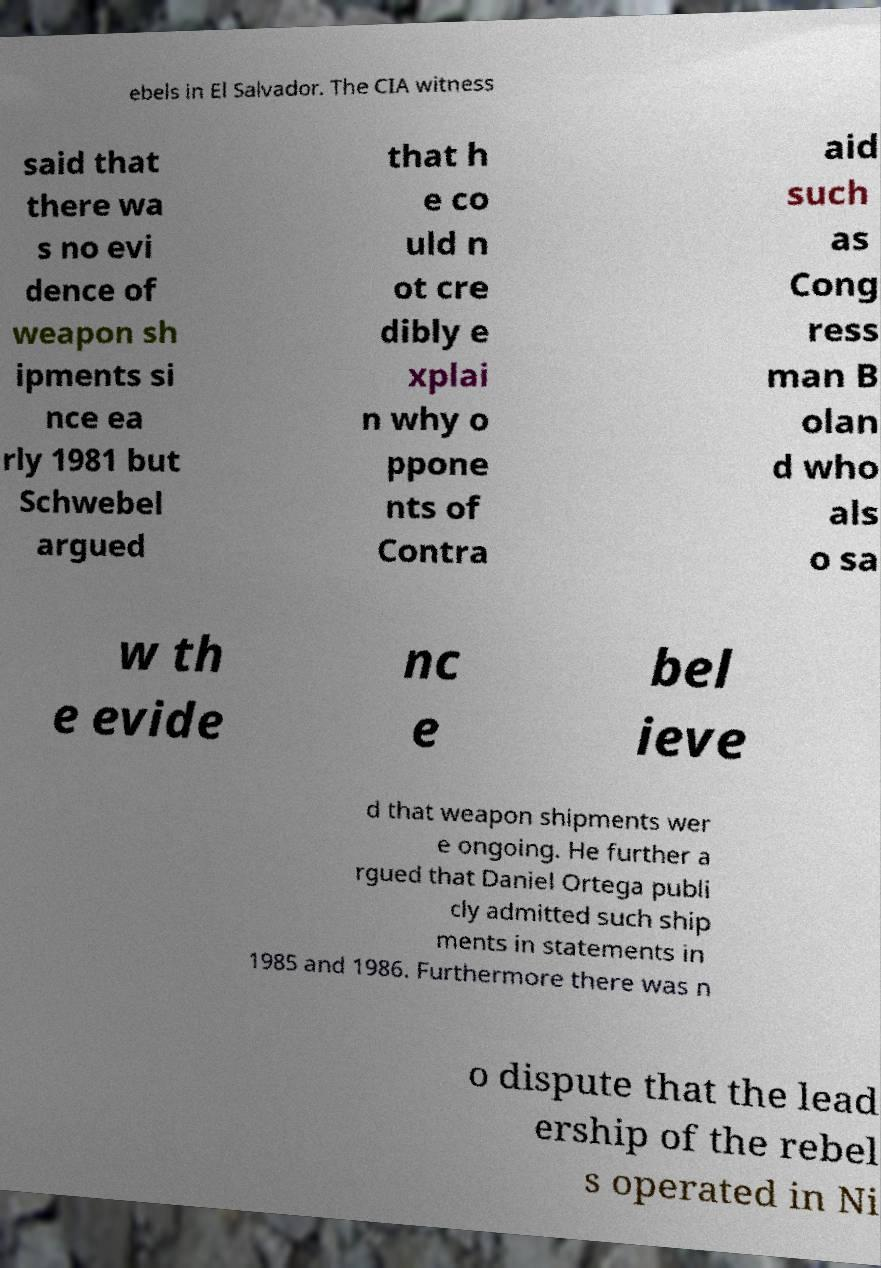Please identify and transcribe the text found in this image. ebels in El Salvador. The CIA witness said that there wa s no evi dence of weapon sh ipments si nce ea rly 1981 but Schwebel argued that h e co uld n ot cre dibly e xplai n why o ppone nts of Contra aid such as Cong ress man B olan d who als o sa w th e evide nc e bel ieve d that weapon shipments wer e ongoing. He further a rgued that Daniel Ortega publi cly admitted such ship ments in statements in 1985 and 1986. Furthermore there was n o dispute that the lead ership of the rebel s operated in Ni 